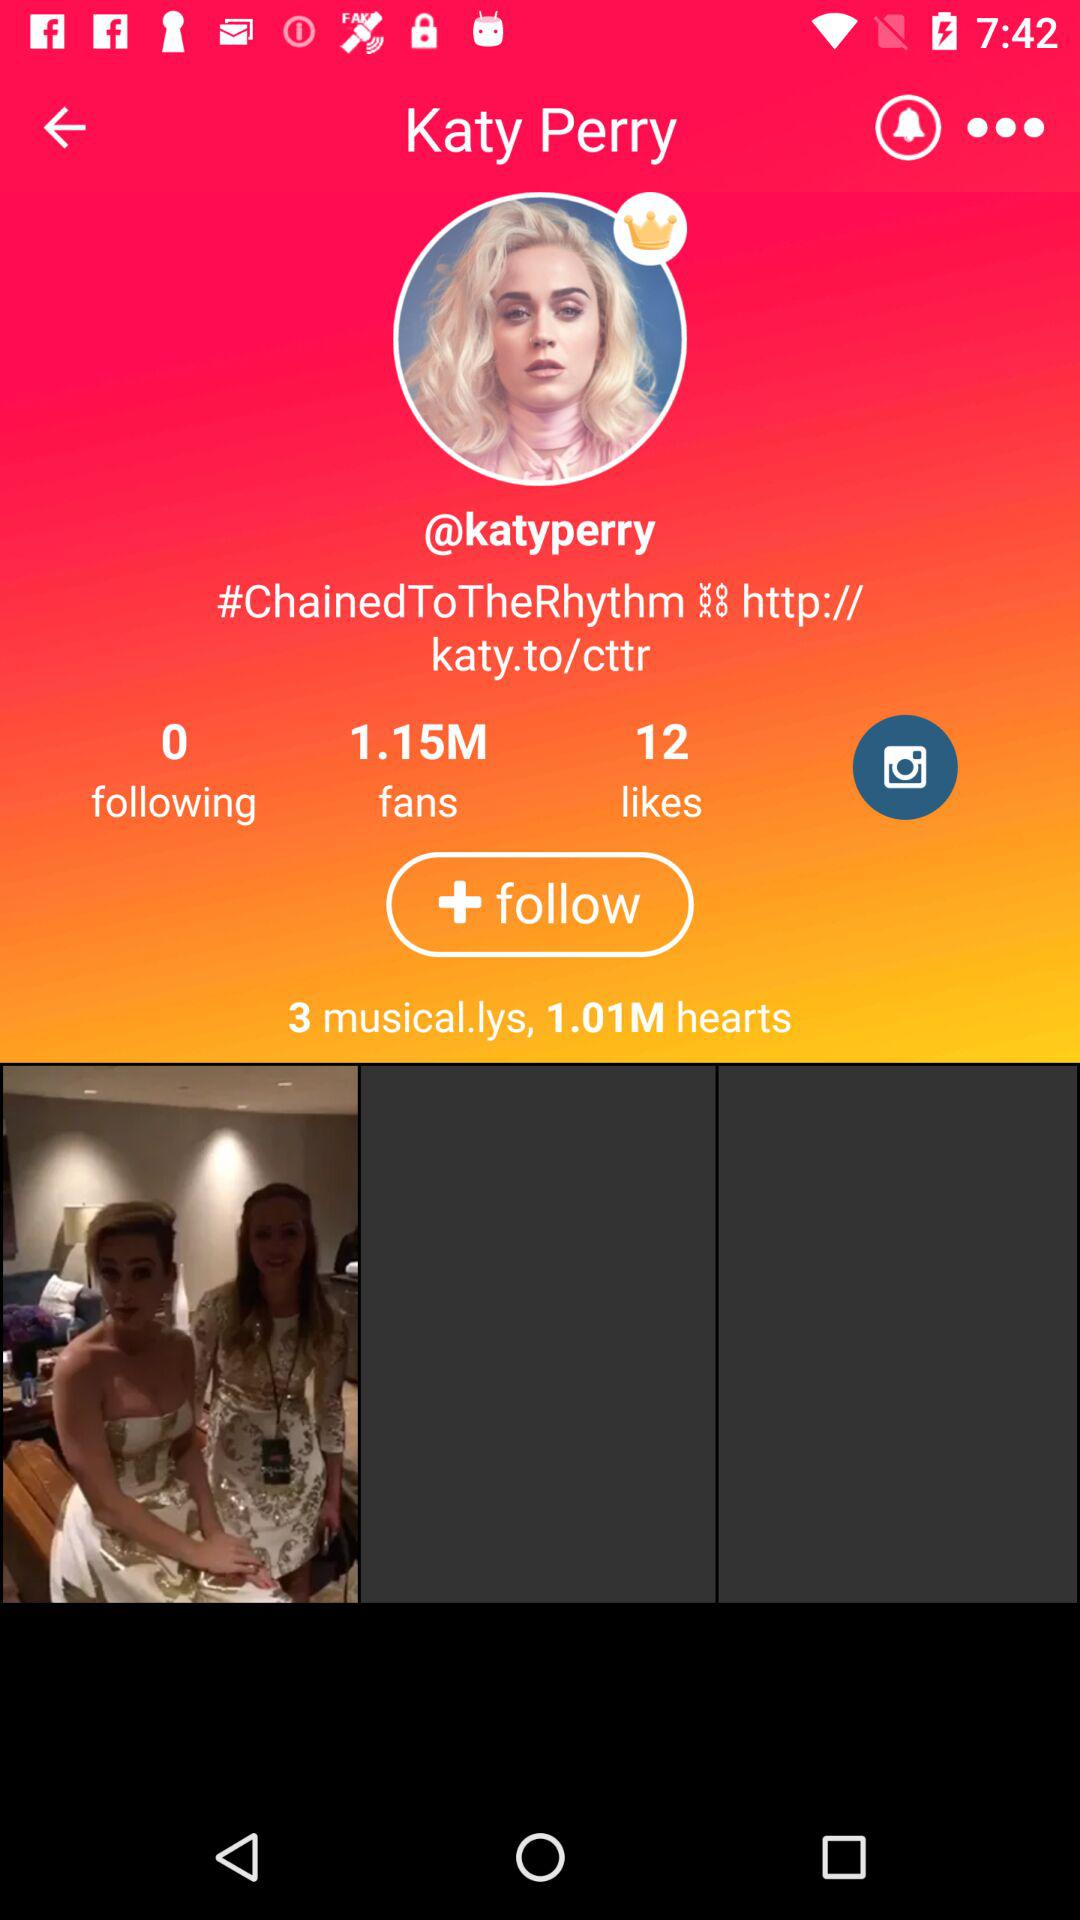What is the user name? The user name is Katy Perry. 